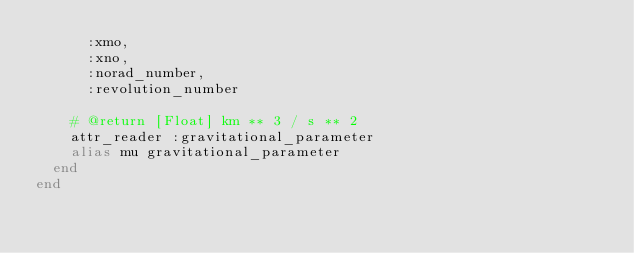Convert code to text. <code><loc_0><loc_0><loc_500><loc_500><_Ruby_>      :xmo,
      :xno,
      :norad_number,
      :revolution_number

    # @return [Float] km ** 3 / s ** 2
    attr_reader :gravitational_parameter
    alias mu gravitational_parameter
  end
end
</code> 